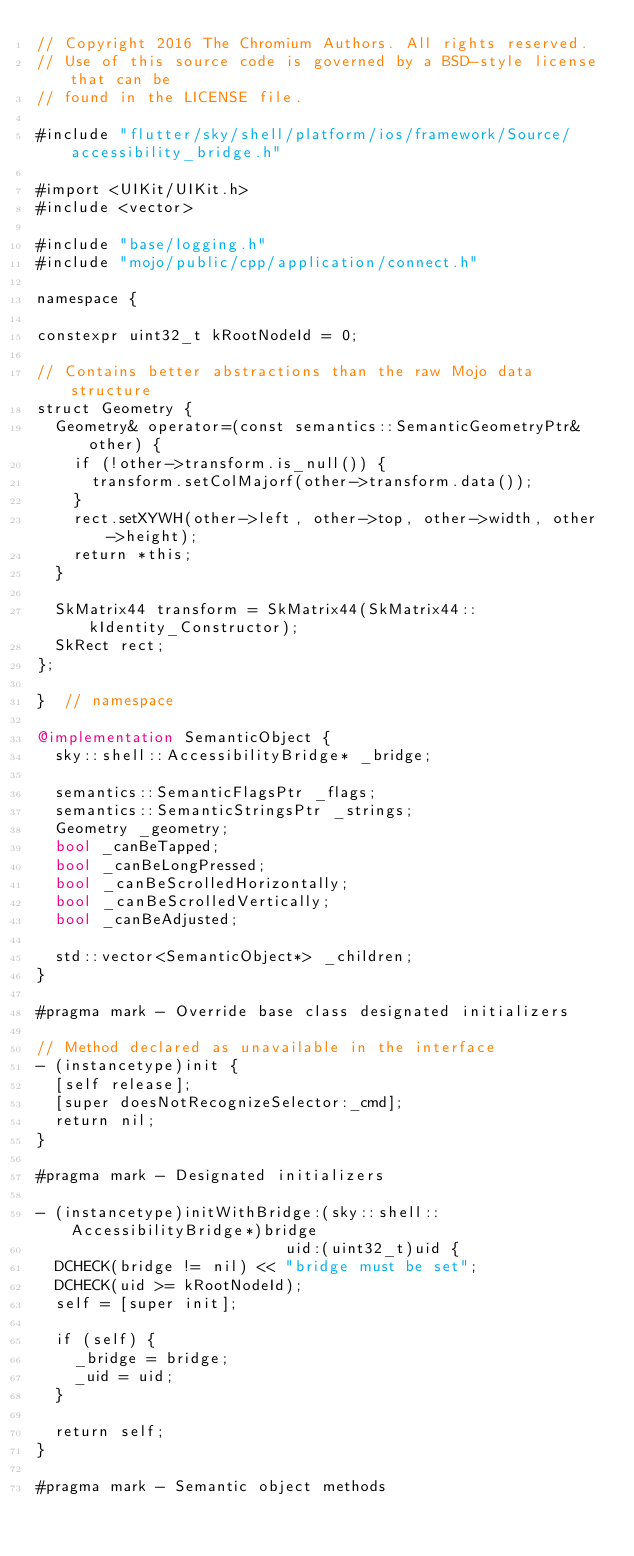<code> <loc_0><loc_0><loc_500><loc_500><_ObjectiveC_>// Copyright 2016 The Chromium Authors. All rights reserved.
// Use of this source code is governed by a BSD-style license that can be
// found in the LICENSE file.

#include "flutter/sky/shell/platform/ios/framework/Source/accessibility_bridge.h"

#import <UIKit/UIKit.h>
#include <vector>

#include "base/logging.h"
#include "mojo/public/cpp/application/connect.h"

namespace {

constexpr uint32_t kRootNodeId = 0;

// Contains better abstractions than the raw Mojo data structure
struct Geometry {
  Geometry& operator=(const semantics::SemanticGeometryPtr& other) {
    if (!other->transform.is_null()) {
      transform.setColMajorf(other->transform.data());
    }
    rect.setXYWH(other->left, other->top, other->width, other->height);
    return *this;
  }

  SkMatrix44 transform = SkMatrix44(SkMatrix44::kIdentity_Constructor);
  SkRect rect;
};

}  // namespace

@implementation SemanticObject {
  sky::shell::AccessibilityBridge* _bridge;

  semantics::SemanticFlagsPtr _flags;
  semantics::SemanticStringsPtr _strings;
  Geometry _geometry;
  bool _canBeTapped;
  bool _canBeLongPressed;
  bool _canBeScrolledHorizontally;
  bool _canBeScrolledVertically;
  bool _canBeAdjusted;

  std::vector<SemanticObject*> _children;
}

#pragma mark - Override base class designated initializers

// Method declared as unavailable in the interface
- (instancetype)init {
  [self release];
  [super doesNotRecognizeSelector:_cmd];
  return nil;
}

#pragma mark - Designated initializers

- (instancetype)initWithBridge:(sky::shell::AccessibilityBridge*)bridge
                           uid:(uint32_t)uid {
  DCHECK(bridge != nil) << "bridge must be set";
  DCHECK(uid >= kRootNodeId);
  self = [super init];

  if (self) {
    _bridge = bridge;
    _uid = uid;
  }

  return self;
}

#pragma mark - Semantic object methods
</code> 